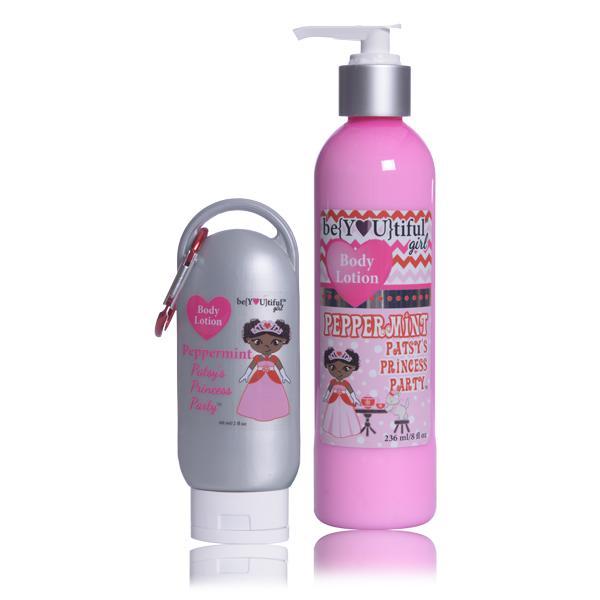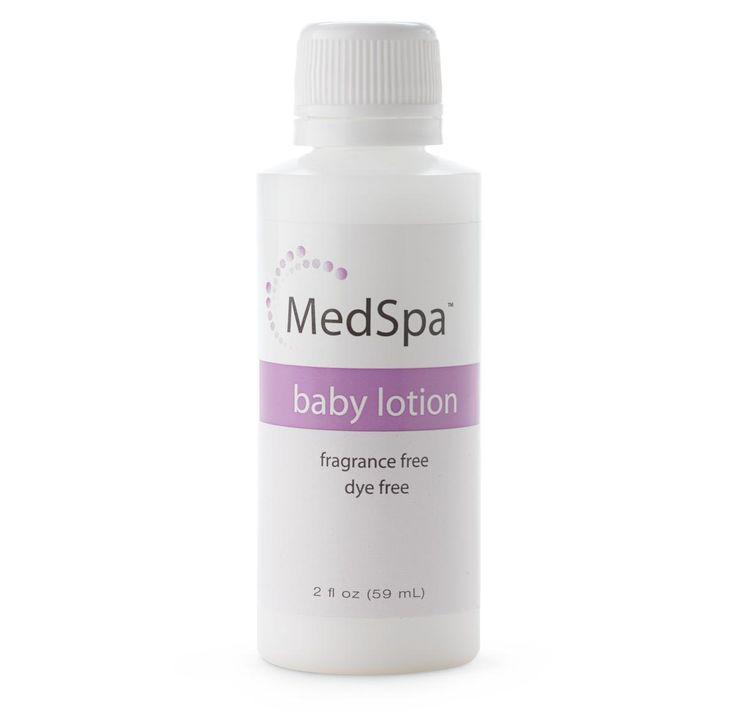The first image is the image on the left, the second image is the image on the right. Given the left and right images, does the statement "There are three items." hold true? Answer yes or no. Yes. 